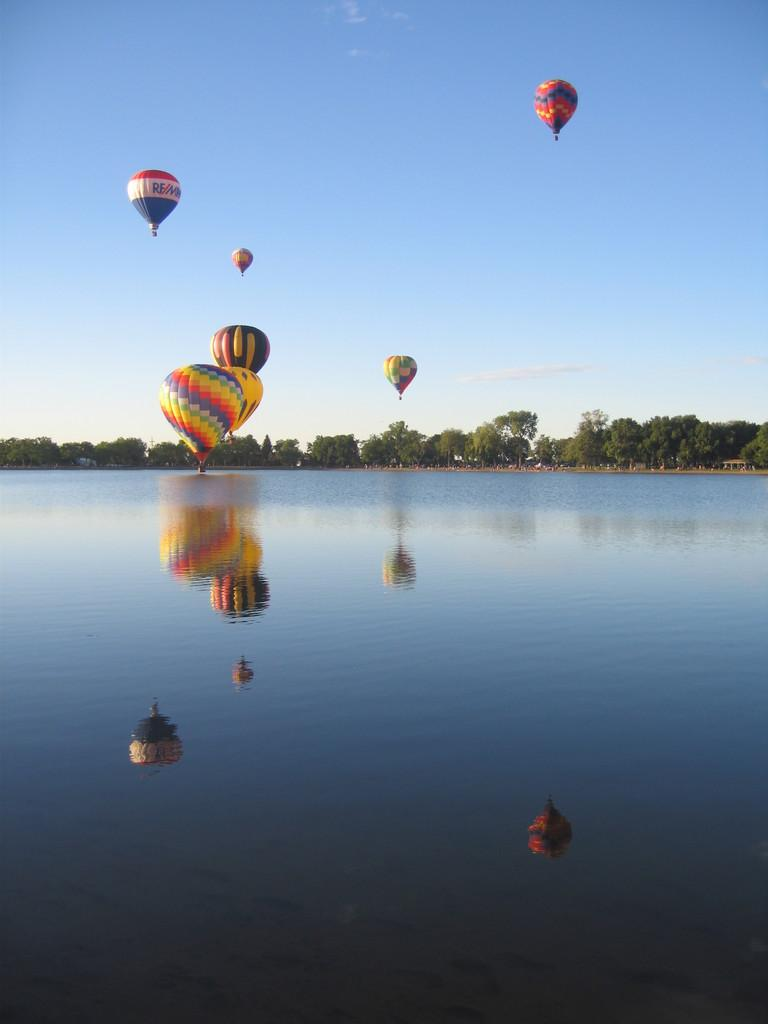What type of natural feature is at the bottom of the image? There is a river at the bottom of the image. What can be seen in the background of the image? There are trees in the background of the image. What are the objects in the air in the image? There are parachutes in the air. What is visible at the top of the image? The sky is visible at the top of the image. What time of day is the beginner's idea being discussed in the image? There is no discussion or idea present in the image, and the time of day cannot be determined from the image alone. Is the night sky visible in the image? No, the sky visible in the image is not a night sky; it appears to be daytime based on the presence of sunlight. 